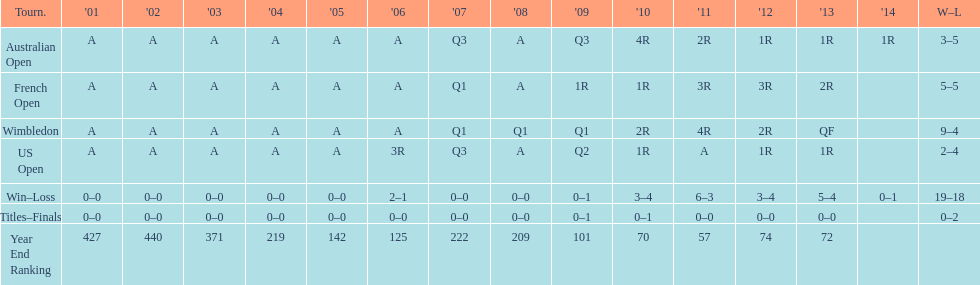What was the total number of matches played from 2001 to 2014? 37. 